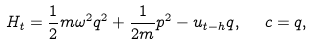Convert formula to latex. <formula><loc_0><loc_0><loc_500><loc_500>H _ { t } = \frac { 1 } { 2 } m \omega ^ { 2 } q ^ { 2 } + \frac { 1 } { 2 m } p ^ { 2 } - u _ { t - h } q , \ \ c = q ,</formula> 